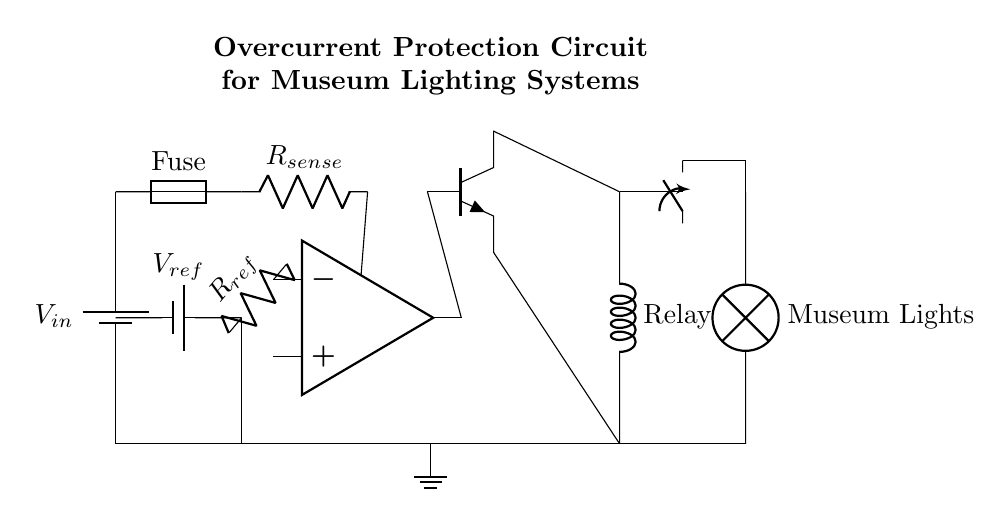what type of component is used for overcurrent protection? A fuse is utilized in this circuit for overcurrent protection, indicated by the labeled fuse component that interrupts the current flow in case of excess current.
Answer: fuse what is the reference voltage in the circuit? The circuit uses a reference voltage supplied by a battery, depicted by the label indicating it as V_ref. The exact value is not specified in the diagram.
Answer: V_ref how does the circuit control the load? The circuit controls the load using a relay that is activated by a transistor, which receives its base input from an operational amplifier's output. This connection ensures that when overcurrent is detected, the relay is switched off, cutting power to the load.
Answer: relay what is the function of the current sensing resistor? The current sensing resistor measures the current flowing through the circuit by generating a voltage drop proportional to the current, which is then fed to the operational amplifier for comparison with the reference voltage.
Answer: measure current how many major components are used in the circuit? The diagram contains six major components, including a fuse, current sensing resistor, operational amplifier, transistor, relay, and load (museum lights). Each component plays a specific role in achieving overcurrent protection.
Answer: six how does the comparator contribute to the circuit? The comparator, represented by the operational amplifier, compares the voltage from the current sensing resistor with the reference voltage. When the sensed voltage exceeds the reference, it changes the output to control the transistor, which in turn switches off the relay and stops the current to the load.
Answer: control current what happens to the load during overcurrent conditions? During overcurrent conditions, the comparator triggers the transistor to deactivate the relay, which disconnects the load from the power supply, thereby protecting the museum lighting system from potential damage.
Answer: disconnected 